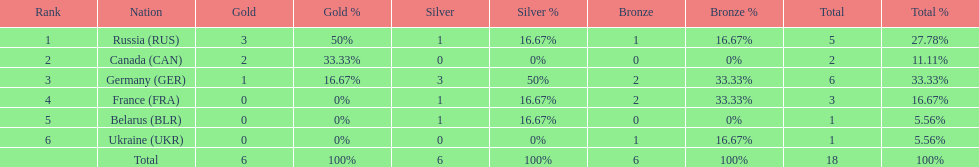How many silver medals did belarus win? 1. 